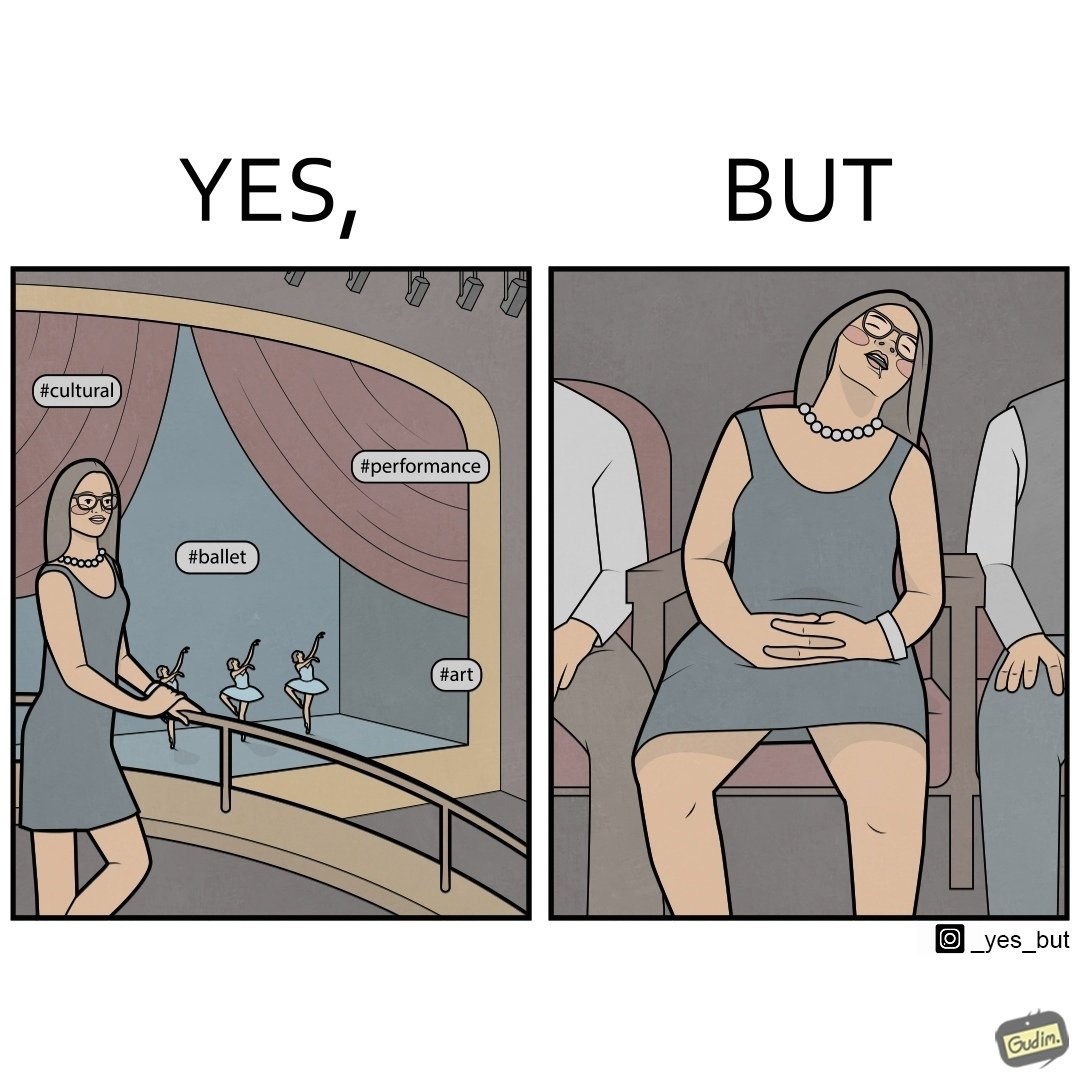Explain why this image is satirical. The image is ironic, because in the first image the woman is trying to show off how much she likes ballet dance performance by posting a photo attending some program but in the same program she is seen sleeping on the chair 